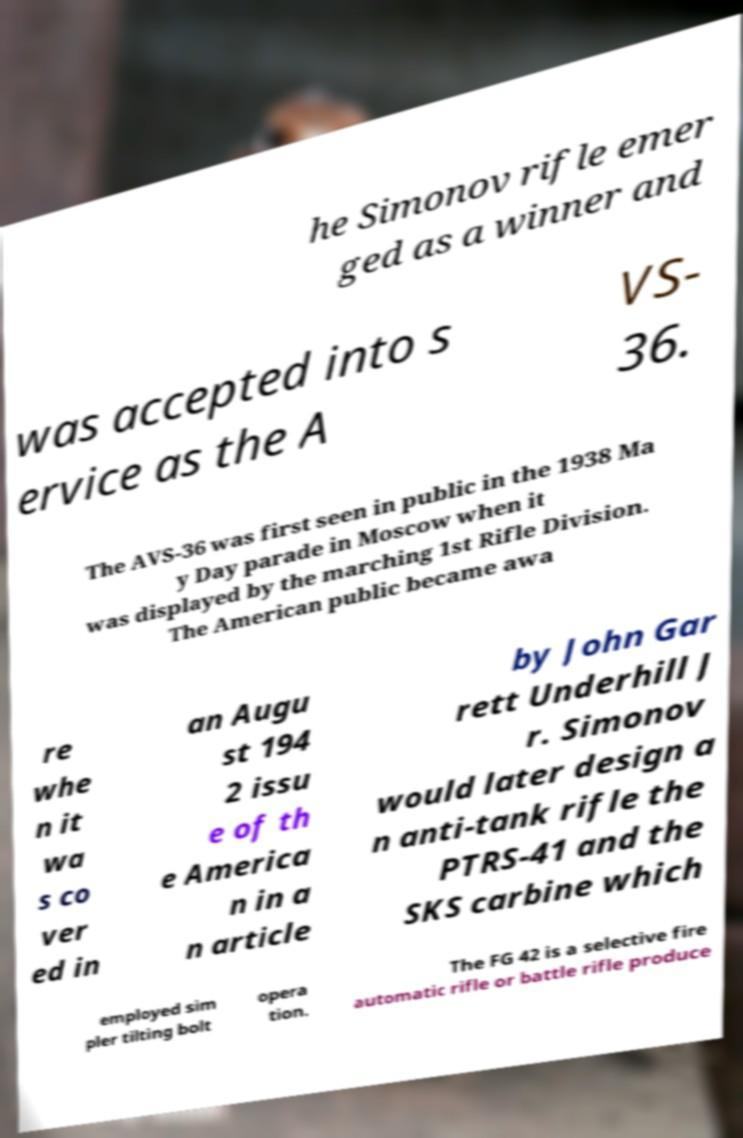For documentation purposes, I need the text within this image transcribed. Could you provide that? he Simonov rifle emer ged as a winner and was accepted into s ervice as the A VS- 36. The AVS-36 was first seen in public in the 1938 Ma y Day parade in Moscow when it was displayed by the marching 1st Rifle Division. The American public became awa re whe n it wa s co ver ed in an Augu st 194 2 issu e of th e America n in a n article by John Gar rett Underhill J r. Simonov would later design a n anti-tank rifle the PTRS-41 and the SKS carbine which employed sim pler tilting bolt opera tion. The FG 42 is a selective fire automatic rifle or battle rifle produce 